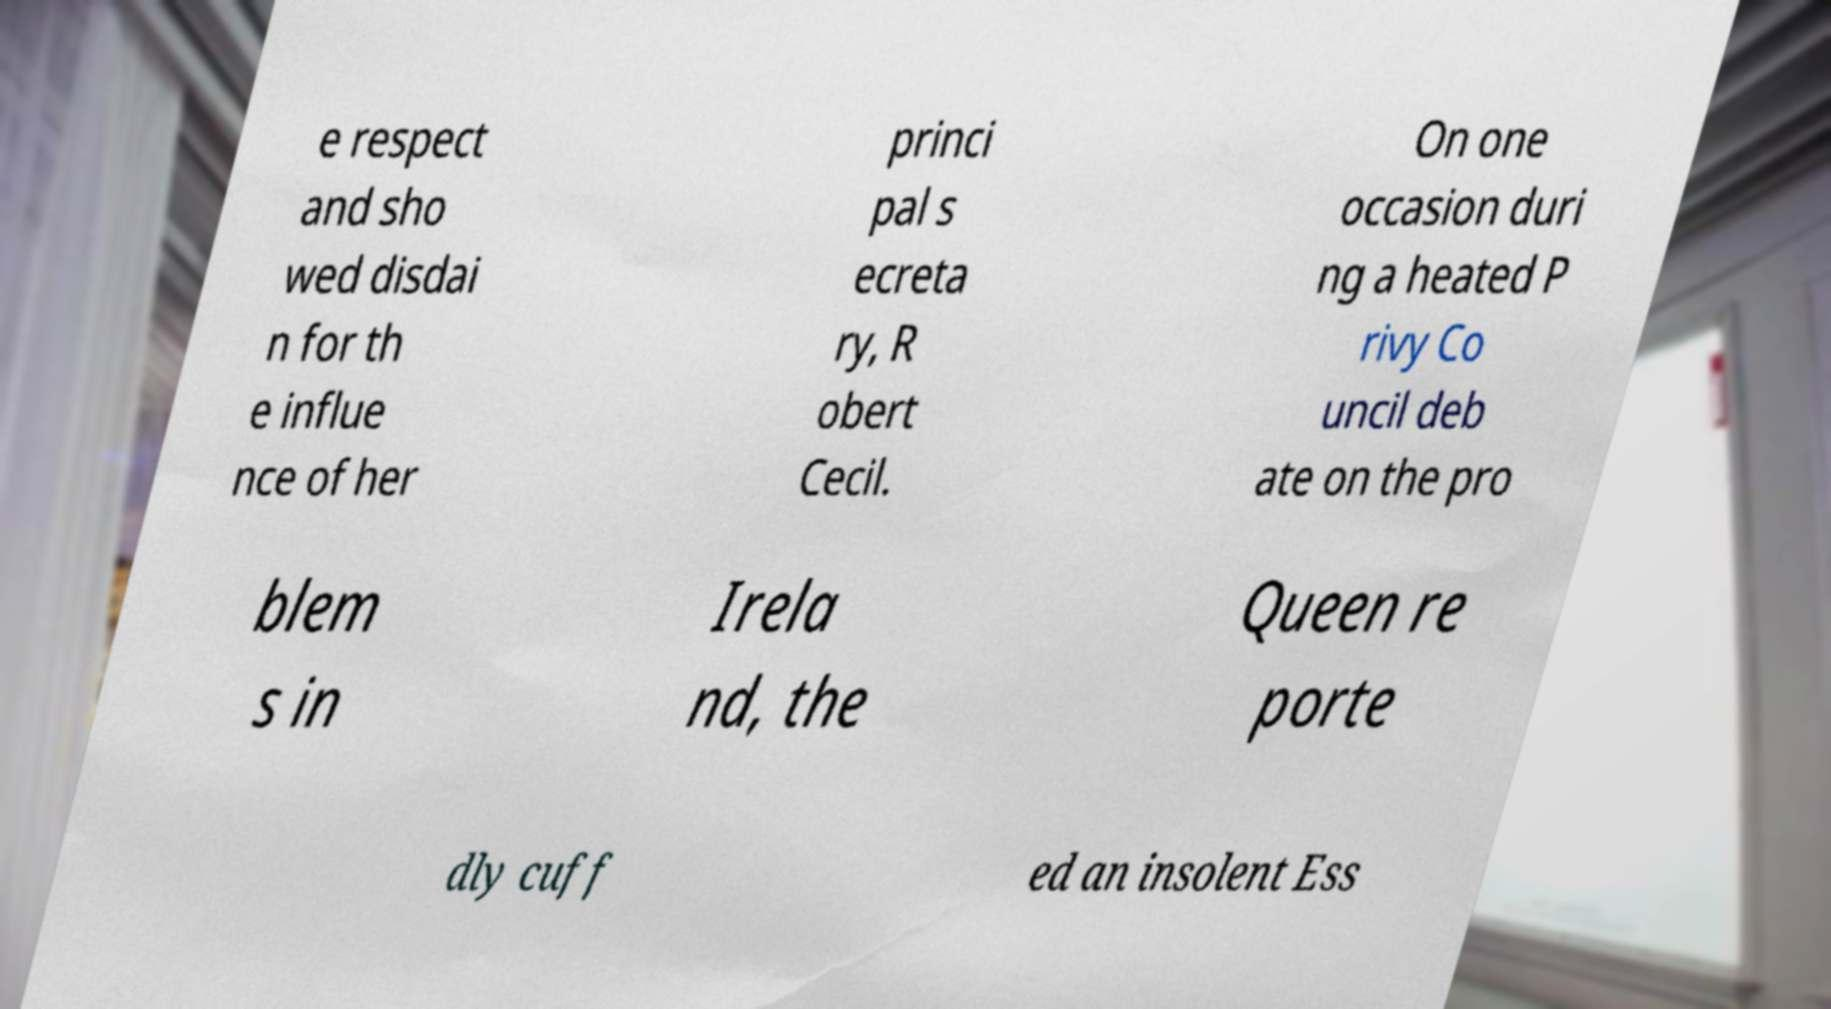I need the written content from this picture converted into text. Can you do that? e respect and sho wed disdai n for th e influe nce of her princi pal s ecreta ry, R obert Cecil. On one occasion duri ng a heated P rivy Co uncil deb ate on the pro blem s in Irela nd, the Queen re porte dly cuff ed an insolent Ess 